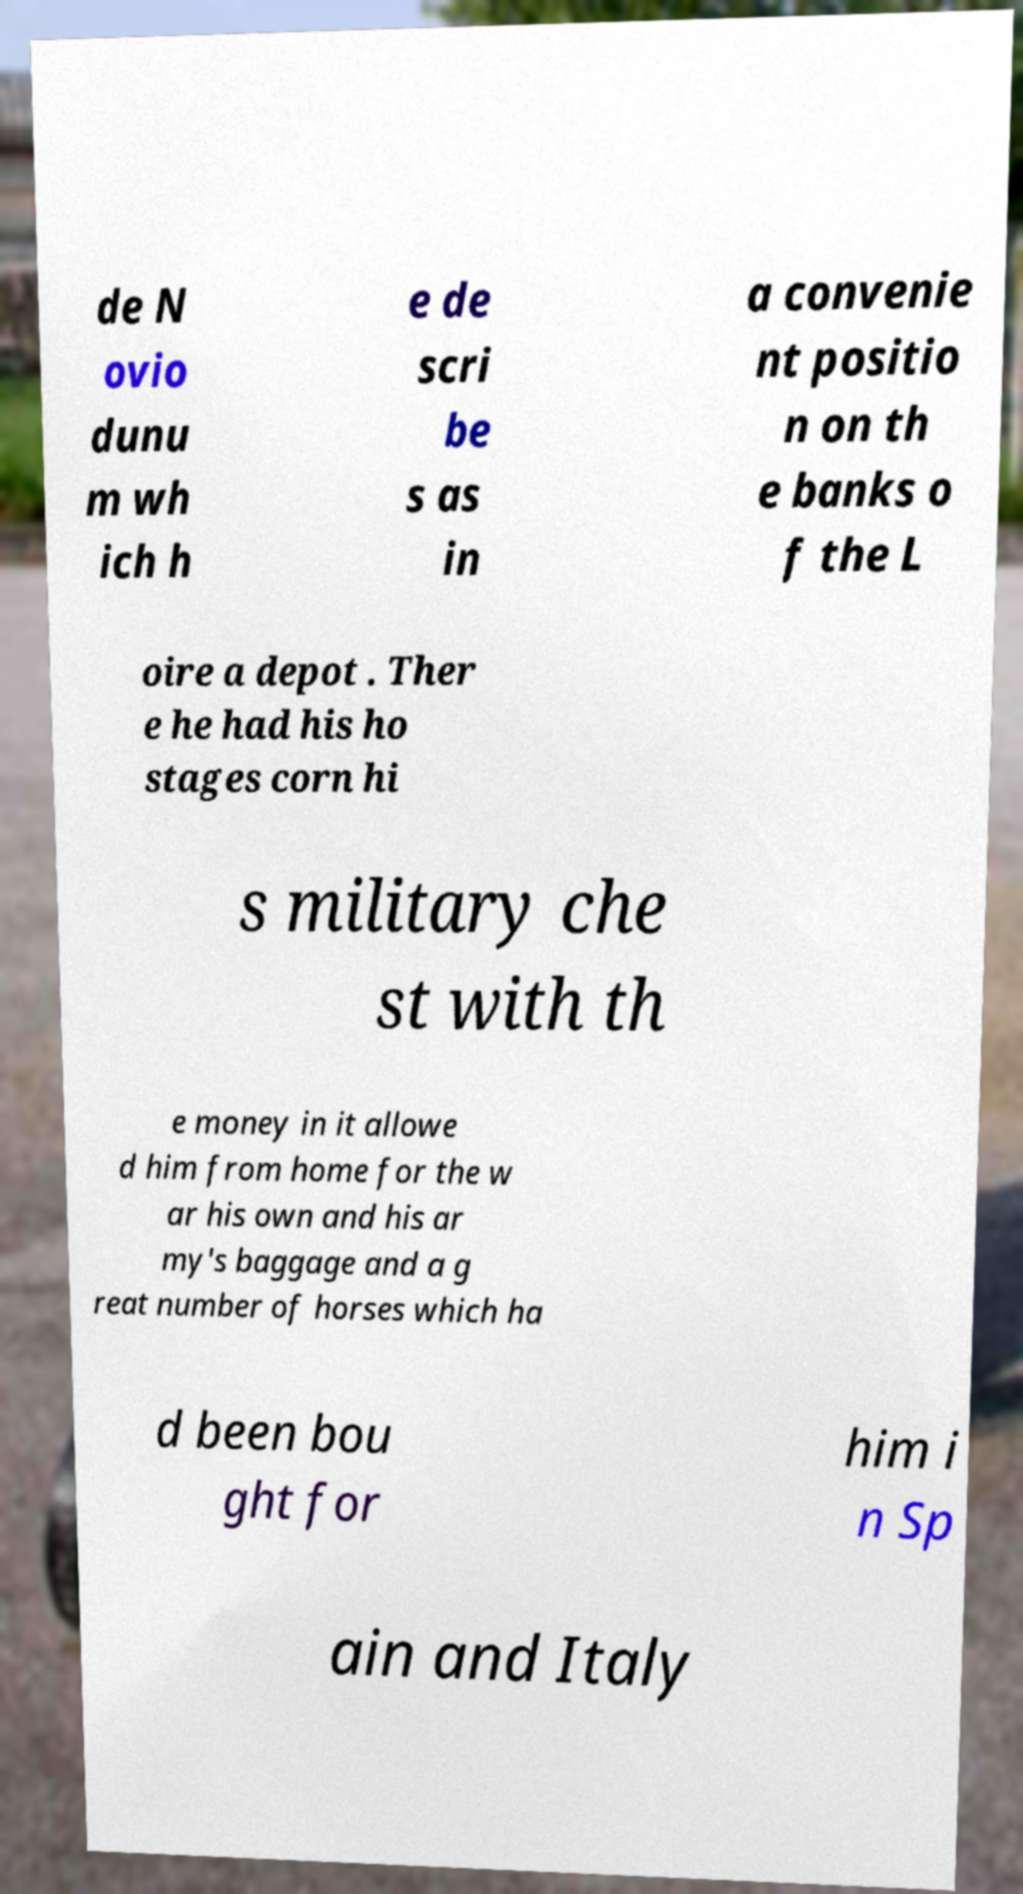Please identify and transcribe the text found in this image. de N ovio dunu m wh ich h e de scri be s as in a convenie nt positio n on th e banks o f the L oire a depot . Ther e he had his ho stages corn hi s military che st with th e money in it allowe d him from home for the w ar his own and his ar my's baggage and a g reat number of horses which ha d been bou ght for him i n Sp ain and Italy 